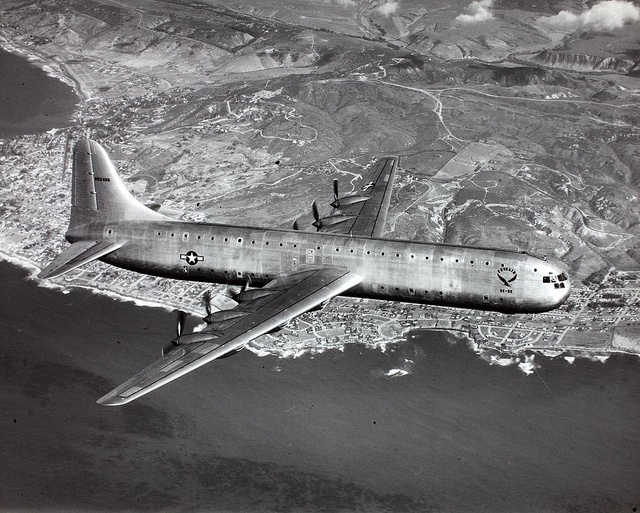Describe the objects in this image and their specific colors. I can see airplane in gray, darkgray, lightgray, and black tones and bird in gray, black, and darkgray tones in this image. 